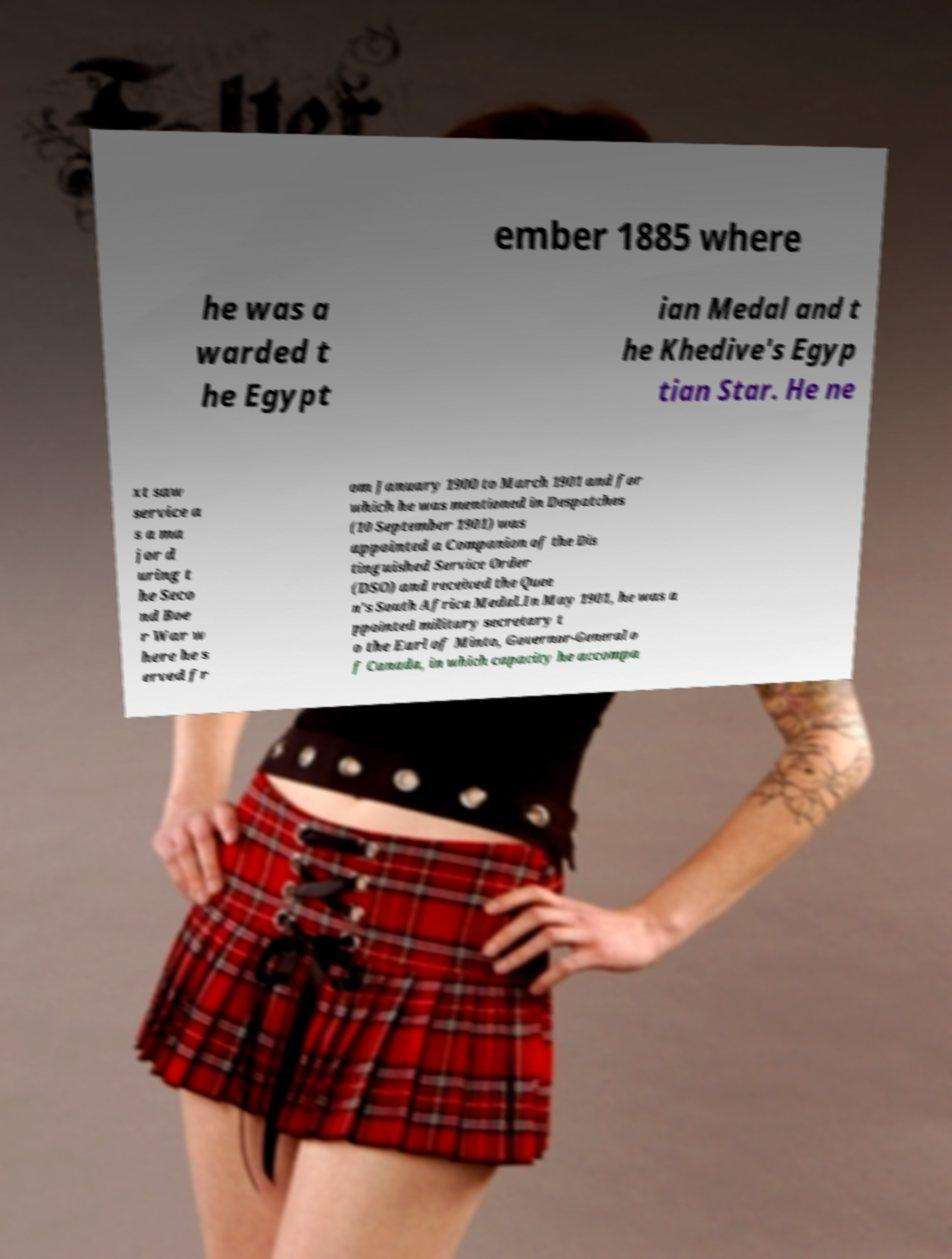Could you extract and type out the text from this image? ember 1885 where he was a warded t he Egypt ian Medal and t he Khedive's Egyp tian Star. He ne xt saw service a s a ma jor d uring t he Seco nd Boe r War w here he s erved fr om January 1900 to March 1901 and for which he was mentioned in Despatches (10 September 1901) was appointed a Companion of the Dis tinguished Service Order (DSO) and received the Quee n's South Africa Medal.In May 1901, he was a ppointed military secretary t o the Earl of Minto, Governor-General o f Canada, in which capacity he accompa 